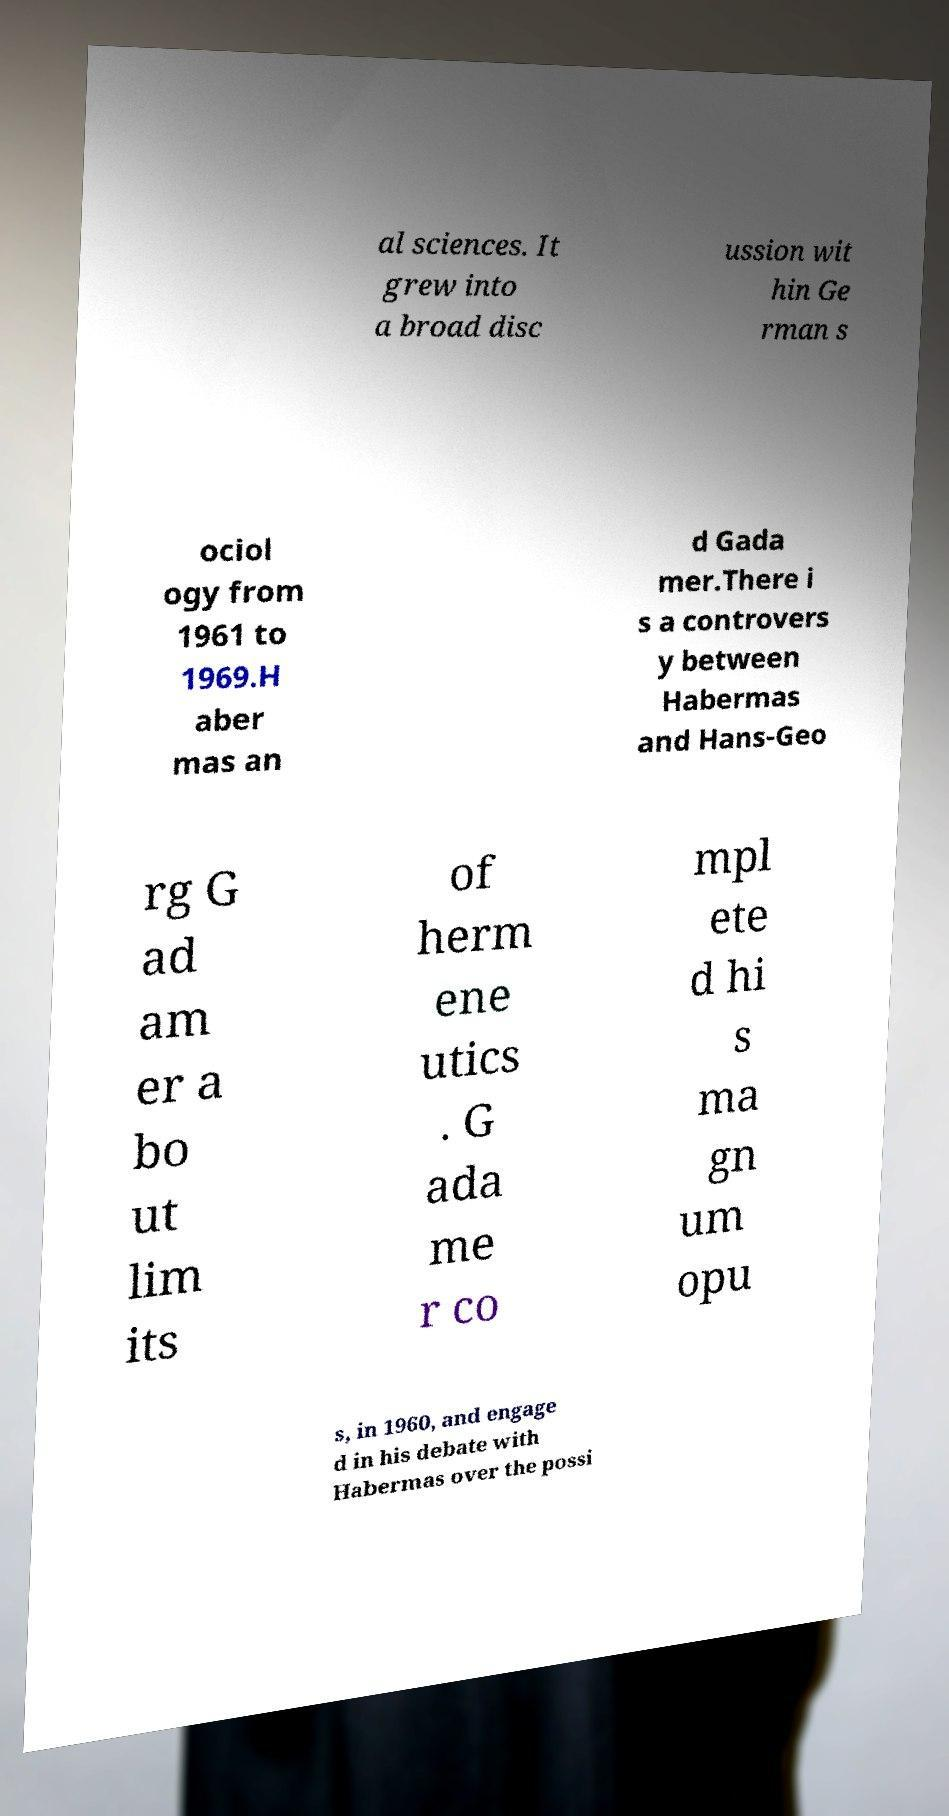For documentation purposes, I need the text within this image transcribed. Could you provide that? al sciences. It grew into a broad disc ussion wit hin Ge rman s ociol ogy from 1961 to 1969.H aber mas an d Gada mer.There i s a controvers y between Habermas and Hans-Geo rg G ad am er a bo ut lim its of herm ene utics . G ada me r co mpl ete d hi s ma gn um opu s, in 1960, and engage d in his debate with Habermas over the possi 